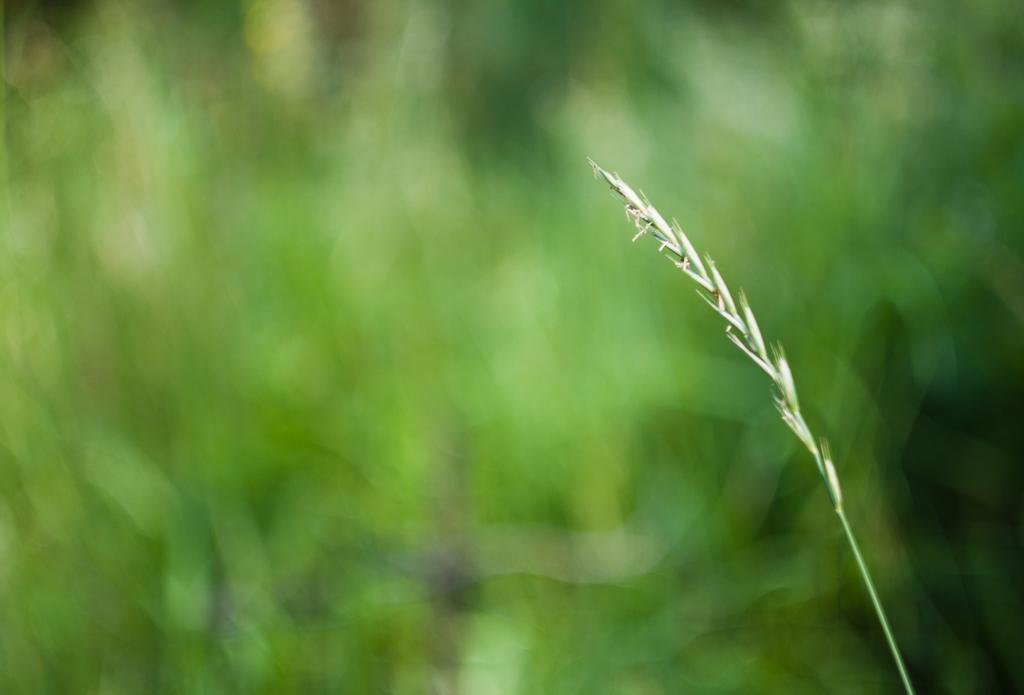What type of plant is featured in the image? There is hierochloe in the image. What color is the background of the image? The background of the image is green. How does the hierochloe plant demand attention in the image? The hierochloe plant does not demand attention in the image; it is simply a part of the scene. 